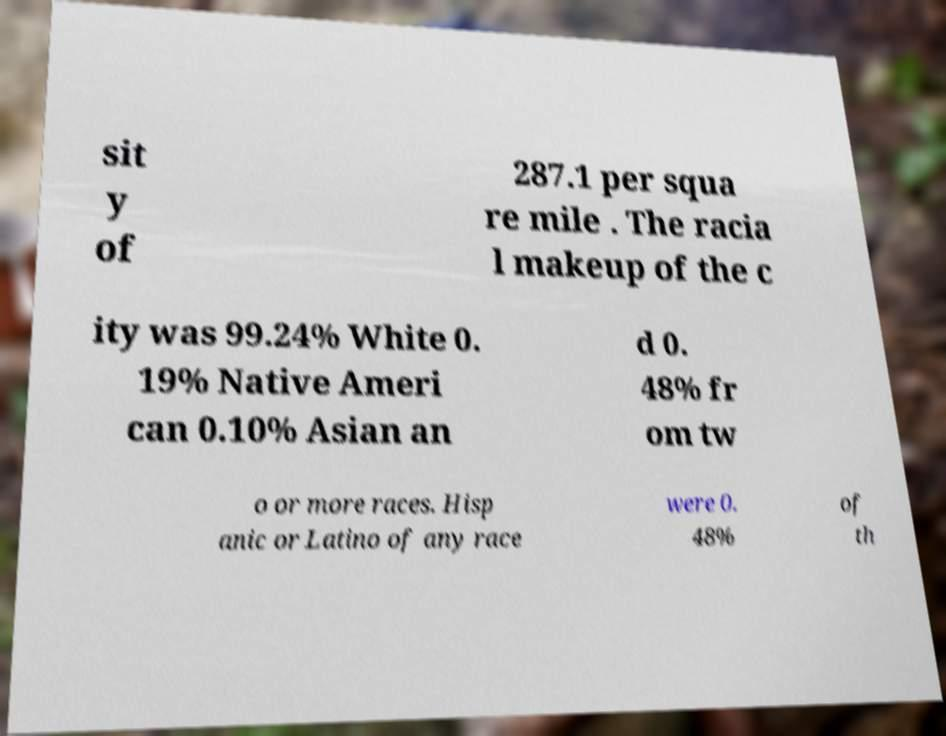Can you accurately transcribe the text from the provided image for me? sit y of 287.1 per squa re mile . The racia l makeup of the c ity was 99.24% White 0. 19% Native Ameri can 0.10% Asian an d 0. 48% fr om tw o or more races. Hisp anic or Latino of any race were 0. 48% of th 